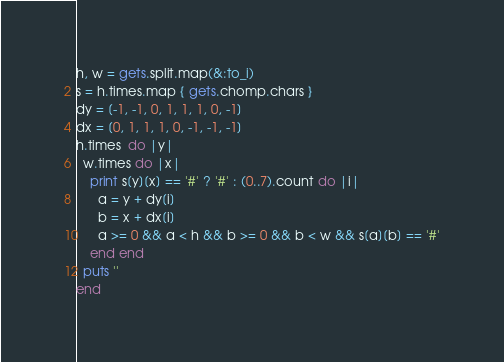Convert code to text. <code><loc_0><loc_0><loc_500><loc_500><_Ruby_>h, w = gets.split.map(&:to_i)
s = h.times.map { gets.chomp.chars }
dy = [-1, -1, 0, 1, 1, 1, 0, -1]
dx = [0, 1, 1, 1, 0, -1, -1, -1]
h.times  do |y|
  w.times do |x|
    print s[y][x] == '#' ? '#' : (0..7).count do |i|
      a = y + dy[i]
      b = x + dx[i]
      a >= 0 && a < h && b >= 0 && b < w && s[a][b] == '#'
    end end
  puts ''
end
</code> 